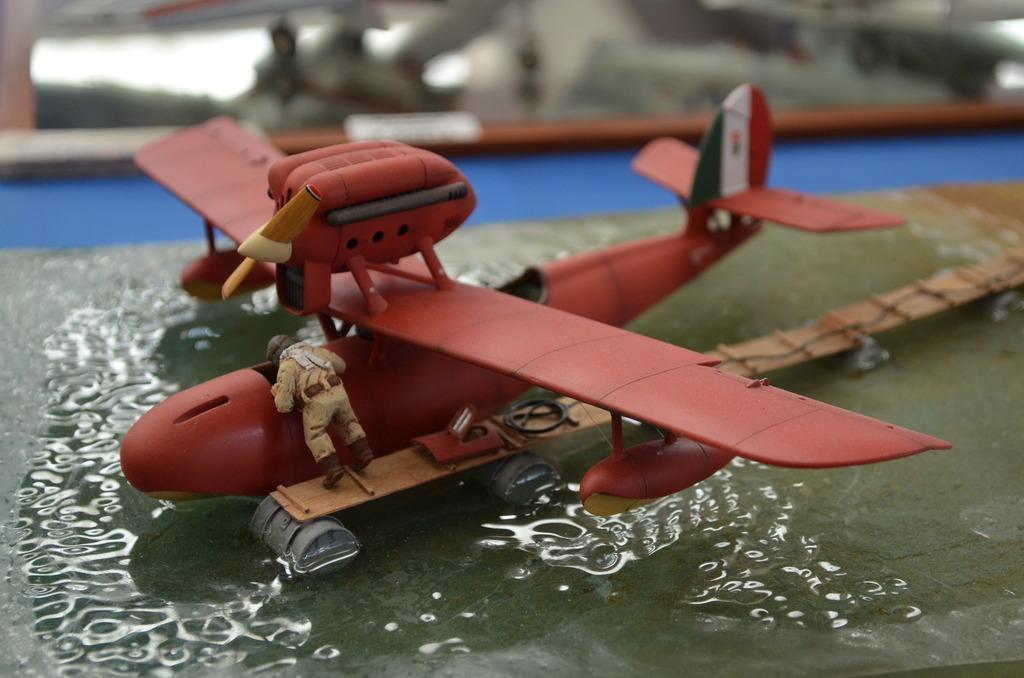How would you summarize this image in a sentence or two? In the image we can see a toy, flying jet. There is a toy of person wearing clothes, helmet and shoes. There is even water and the background is blurred. 